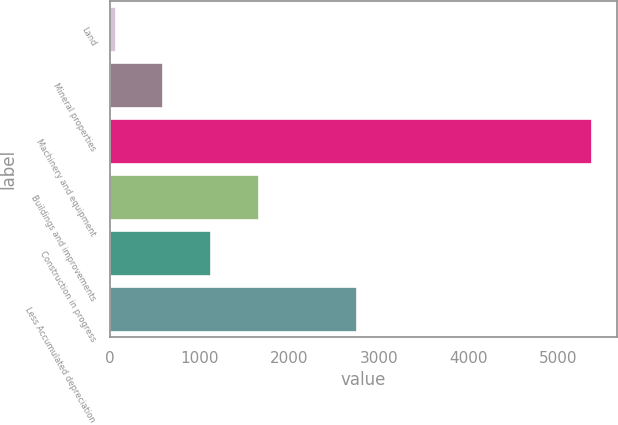Convert chart. <chart><loc_0><loc_0><loc_500><loc_500><bar_chart><fcel>Land<fcel>Mineral properties<fcel>Machinery and equipment<fcel>Buildings and improvements<fcel>Construction in progress<fcel>Less Accumulated depreciation<nl><fcel>60.2<fcel>593.04<fcel>5388.6<fcel>1658.72<fcel>1125.88<fcel>2757.1<nl></chart> 